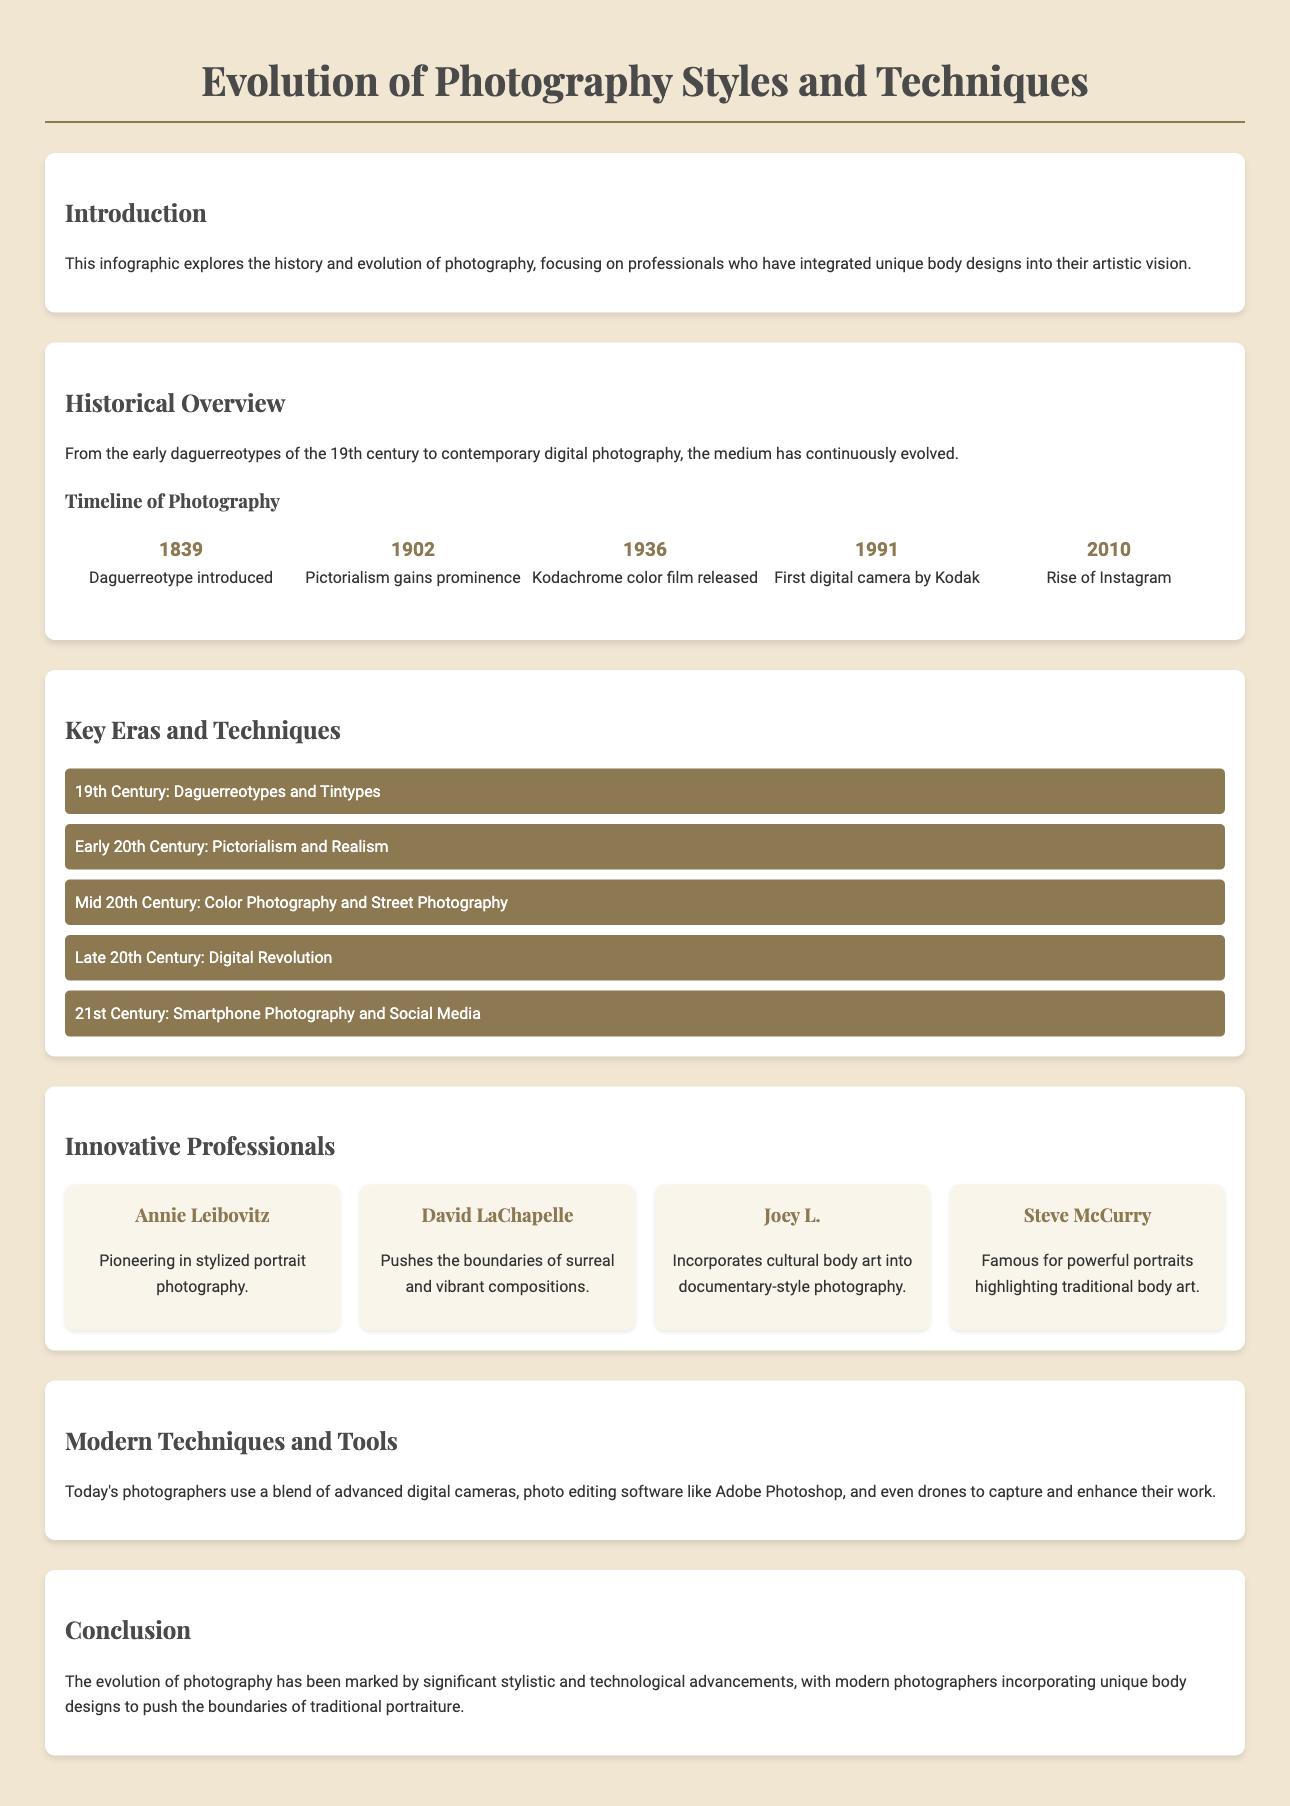What year was the daguerreotype introduced? The document specifies that the daguerreotype was introduced in 1839.
Answer: 1839 Who is known for pioneering in stylized portrait photography? The infographic lists Annie Leibovitz as a pioneering photographer in stylized portrait photography.
Answer: Annie Leibovitz What significant photography technology was released in 1936? The document states that 1936 saw the release of Kodachrome color film.
Answer: Kodachrome color film Which technique gained prominence in 1902? The infographic indicates that Pictorialism gained prominence in 1902.
Answer: Pictorialism What do modern photographers use in addition to digital cameras? According to the document, modern photographers use photo editing software like Adobe Photoshop as well.
Answer: Adobe Photoshop What does the document imply about body designs in modern photography? The conclusion states that modern photographers incorporate unique body designs in their work.
Answer: Unique body designs What era is associated with the rise of Instagram? The infographic notes that Instagram rose in popularity around 2010.
Answer: 2010 Who pushes the boundaries of surreal and vibrant compositions? David LaChapelle is mentioned as a photographer who pushes these boundaries.
Answer: David LaChapelle What is a key feature of the 21st Century photography style? The infographic characterizes 21st Century photography as involving smartphone photography and social media.
Answer: Smartphone Photography and Social Media 